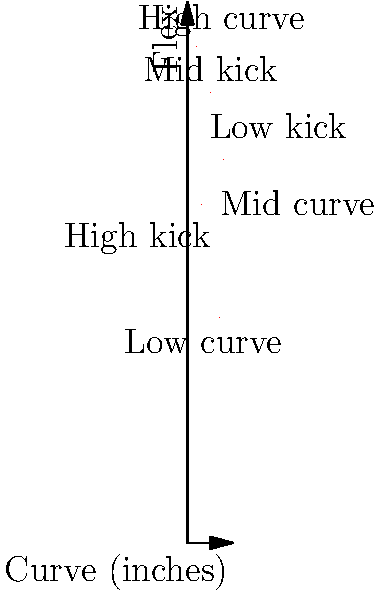Based on the scatter plot showing the relationship between hockey stick curve and flex, which type of stick would be most suitable for a player who prefers a high curve with a low kick point? To answer this question, we need to analyze the scatter plot and understand the relationship between curve, flex, and kick point. Let's break it down step-by-step:

1. The x-axis represents the curve of the stick in inches, with higher values indicating a greater curve.
2. The y-axis represents the flex of the stick, with higher values indicating a stiffer flex.
3. The kick point is related to the flex and is generally categorized as low, mid, or high.

4. Identifying the high curve region:
   - High curve sticks are located on the right side of the plot, approximately 7-10 inches.

5. Identifying the low kick point region:
   - Low kick point sticks typically have higher flex values and are located in the upper portion of the plot.

6. Locating the point that satisfies both conditions:
   - We're looking for a point on the right side of the plot (high curve) and in the upper region (low kick point).
   - The point at coordinates (2, 110) best fits these criteria.

7. Interpreting the result:
   - This point represents a stick with a high curve (close to 2 inches) and a high flex (110), which corresponds to a low kick point.

Therefore, the most suitable stick for a player who prefers a high curve with a low kick point would be represented by the data point at (2, 110) on the scatter plot.
Answer: High curve, high flex stick (represented by the point at (2, 110)) 